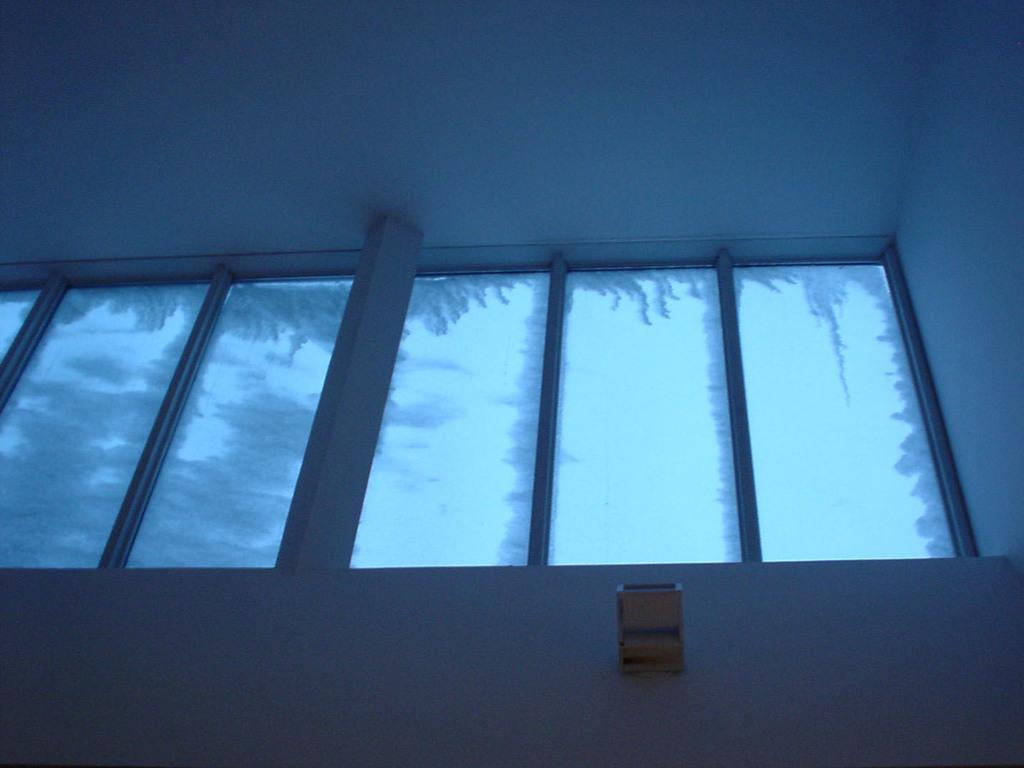Describe this image in one or two sentences. In this picture we can observe windows. We can observe glasses here. In the background there is a wall. 